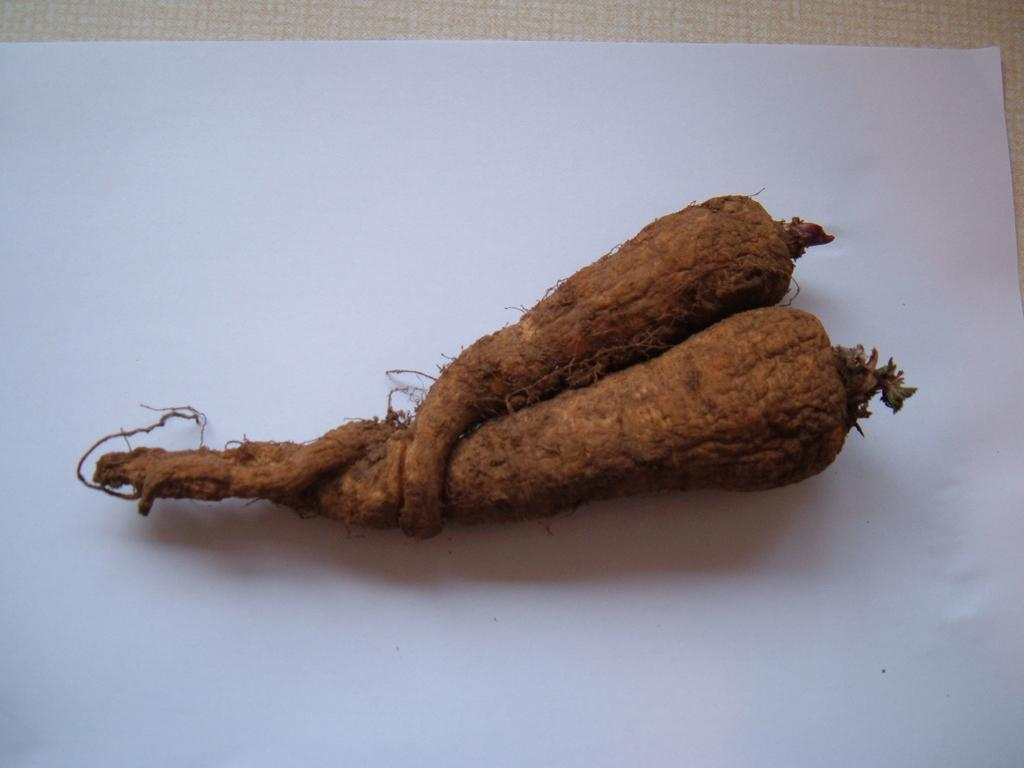What types of food items are present in the image? There are two vegetables in the image. On what surface are the vegetables placed? The vegetables are placed on a white color paper. What type of collar can be seen on the vegetables in the image? There is no collar present on the vegetables in the image. How many worms can be seen crawling on the vegetables in the image? There are no worms present on the vegetables in the image. 